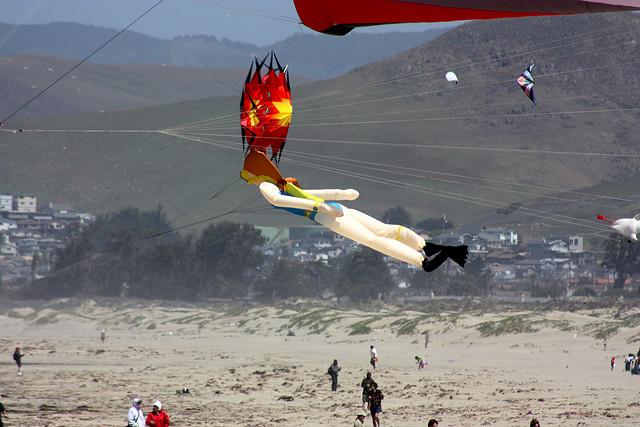Based on the image, what kind of activities can you infer the people might be doing on the beach? Based on the image, it can be inferred that people are primarily engaged in kite flying. The presence of multiple kites in the sky and individuals holding strings indicates this activity. Additionally, some individuals may be observing or assisting with the kites, enjoying a leisurely day at the beach. Other possible activities include walking along the shoreline, socializing with friends and family, and perhaps enjoying a picnic, given the casual, relaxed atmosphere suggested by their attire and behavior. 